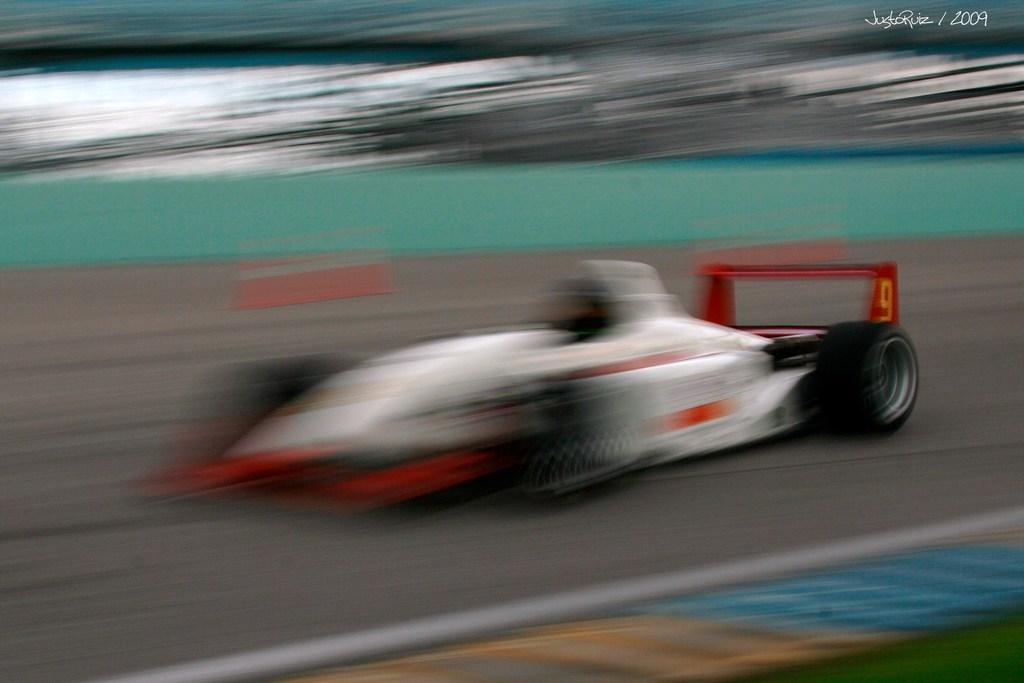What is the main subject of the image? There is a car in the image. What is the car situated on? There is a road in the image. Can you describe the background of the image? The background of the image is blurry. Are there any toys visible on the ground in the image? There is no mention of toys or a ground in the image; it only features a car on a road with a blurry background. Can you see a yak in the image? There is no yak present in the image. 